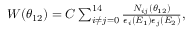<formula> <loc_0><loc_0><loc_500><loc_500>\begin{array} { r } { W ( \theta _ { 1 2 } ) = C \sum _ { i \neq j = 0 } ^ { 1 4 } \frac { N _ { i j } ( \theta _ { 1 2 } ) } { \epsilon _ { i } ( E _ { 1 } ) \epsilon _ { j } ( E _ { 2 } ) } , } \end{array}</formula> 